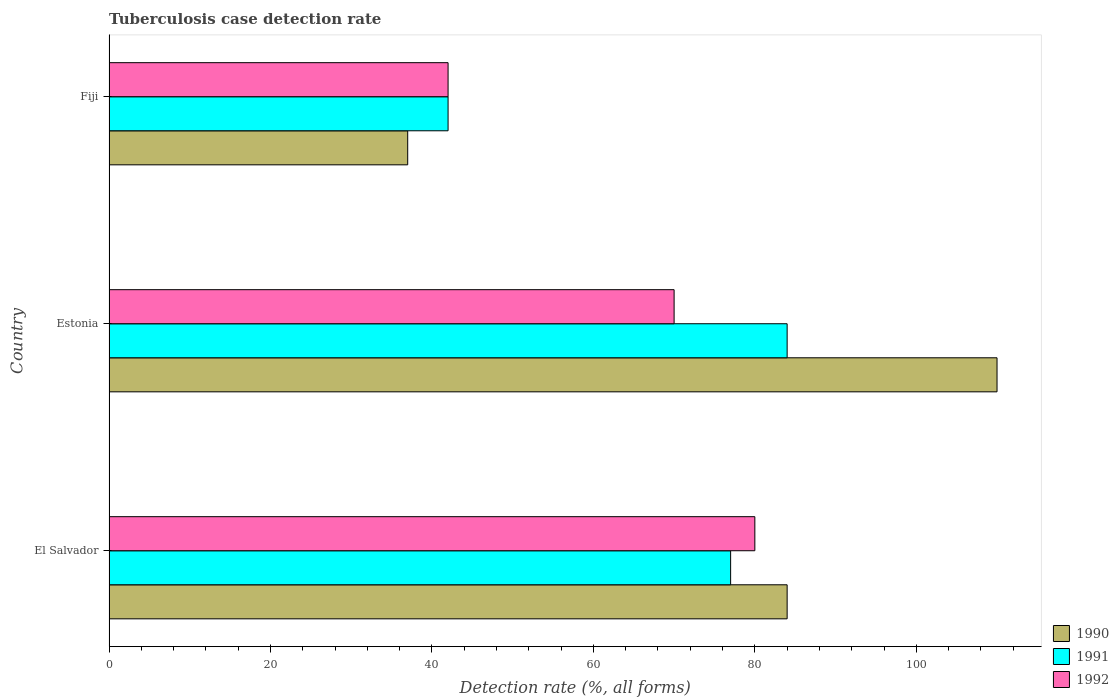How many different coloured bars are there?
Keep it short and to the point. 3. How many groups of bars are there?
Provide a short and direct response. 3. Are the number of bars per tick equal to the number of legend labels?
Your response must be concise. Yes. How many bars are there on the 2nd tick from the top?
Offer a terse response. 3. How many bars are there on the 2nd tick from the bottom?
Provide a succinct answer. 3. What is the label of the 3rd group of bars from the top?
Offer a terse response. El Salvador. Across all countries, what is the maximum tuberculosis case detection rate in in 1990?
Your answer should be very brief. 110. Across all countries, what is the minimum tuberculosis case detection rate in in 1990?
Provide a short and direct response. 37. In which country was the tuberculosis case detection rate in in 1992 maximum?
Offer a very short reply. El Salvador. In which country was the tuberculosis case detection rate in in 1991 minimum?
Offer a very short reply. Fiji. What is the total tuberculosis case detection rate in in 1991 in the graph?
Provide a succinct answer. 203. What is the difference between the tuberculosis case detection rate in in 1992 in El Salvador and the tuberculosis case detection rate in in 1990 in Fiji?
Provide a short and direct response. 43. What is the average tuberculosis case detection rate in in 1992 per country?
Provide a succinct answer. 64. What is the difference between the tuberculosis case detection rate in in 1990 and tuberculosis case detection rate in in 1991 in Estonia?
Make the answer very short. 26. What is the ratio of the tuberculosis case detection rate in in 1992 in Estonia to that in Fiji?
Offer a terse response. 1.67. Is the tuberculosis case detection rate in in 1991 in El Salvador less than that in Fiji?
Give a very brief answer. No. Is the difference between the tuberculosis case detection rate in in 1990 in Estonia and Fiji greater than the difference between the tuberculosis case detection rate in in 1991 in Estonia and Fiji?
Provide a succinct answer. Yes. What is the difference between the highest and the second highest tuberculosis case detection rate in in 1991?
Give a very brief answer. 7. In how many countries, is the tuberculosis case detection rate in in 1991 greater than the average tuberculosis case detection rate in in 1991 taken over all countries?
Keep it short and to the point. 2. Is the sum of the tuberculosis case detection rate in in 1990 in El Salvador and Fiji greater than the maximum tuberculosis case detection rate in in 1992 across all countries?
Your answer should be compact. Yes. What does the 1st bar from the top in El Salvador represents?
Offer a terse response. 1992. How many bars are there?
Keep it short and to the point. 9. Are all the bars in the graph horizontal?
Your answer should be compact. Yes. Does the graph contain any zero values?
Your answer should be compact. No. Where does the legend appear in the graph?
Provide a succinct answer. Bottom right. How are the legend labels stacked?
Offer a very short reply. Vertical. What is the title of the graph?
Your answer should be compact. Tuberculosis case detection rate. What is the label or title of the X-axis?
Keep it short and to the point. Detection rate (%, all forms). What is the Detection rate (%, all forms) in 1990 in El Salvador?
Provide a short and direct response. 84. What is the Detection rate (%, all forms) of 1990 in Estonia?
Make the answer very short. 110. What is the Detection rate (%, all forms) in 1991 in Estonia?
Make the answer very short. 84. What is the Detection rate (%, all forms) in 1992 in Estonia?
Give a very brief answer. 70. What is the Detection rate (%, all forms) in 1991 in Fiji?
Your response must be concise. 42. Across all countries, what is the maximum Detection rate (%, all forms) in 1990?
Keep it short and to the point. 110. Across all countries, what is the maximum Detection rate (%, all forms) in 1991?
Keep it short and to the point. 84. Across all countries, what is the minimum Detection rate (%, all forms) in 1990?
Ensure brevity in your answer.  37. What is the total Detection rate (%, all forms) of 1990 in the graph?
Offer a very short reply. 231. What is the total Detection rate (%, all forms) of 1991 in the graph?
Your answer should be compact. 203. What is the total Detection rate (%, all forms) of 1992 in the graph?
Your answer should be compact. 192. What is the difference between the Detection rate (%, all forms) of 1991 in El Salvador and that in Estonia?
Provide a short and direct response. -7. What is the difference between the Detection rate (%, all forms) in 1990 in El Salvador and that in Fiji?
Ensure brevity in your answer.  47. What is the difference between the Detection rate (%, all forms) of 1991 in El Salvador and that in Fiji?
Provide a short and direct response. 35. What is the difference between the Detection rate (%, all forms) of 1992 in Estonia and that in Fiji?
Provide a succinct answer. 28. What is the difference between the Detection rate (%, all forms) in 1990 in El Salvador and the Detection rate (%, all forms) in 1991 in Estonia?
Make the answer very short. 0. What is the difference between the Detection rate (%, all forms) of 1990 in El Salvador and the Detection rate (%, all forms) of 1992 in Estonia?
Ensure brevity in your answer.  14. What is the difference between the Detection rate (%, all forms) in 1990 in El Salvador and the Detection rate (%, all forms) in 1992 in Fiji?
Make the answer very short. 42. What is the difference between the Detection rate (%, all forms) of 1991 in El Salvador and the Detection rate (%, all forms) of 1992 in Fiji?
Your answer should be compact. 35. What is the difference between the Detection rate (%, all forms) in 1990 in Estonia and the Detection rate (%, all forms) in 1992 in Fiji?
Ensure brevity in your answer.  68. What is the average Detection rate (%, all forms) in 1991 per country?
Keep it short and to the point. 67.67. What is the average Detection rate (%, all forms) of 1992 per country?
Offer a very short reply. 64. What is the difference between the Detection rate (%, all forms) in 1990 and Detection rate (%, all forms) in 1991 in El Salvador?
Provide a succinct answer. 7. What is the difference between the Detection rate (%, all forms) in 1990 and Detection rate (%, all forms) in 1991 in Estonia?
Offer a very short reply. 26. What is the difference between the Detection rate (%, all forms) in 1990 and Detection rate (%, all forms) in 1992 in Estonia?
Ensure brevity in your answer.  40. What is the difference between the Detection rate (%, all forms) of 1991 and Detection rate (%, all forms) of 1992 in Estonia?
Your answer should be very brief. 14. What is the difference between the Detection rate (%, all forms) in 1990 and Detection rate (%, all forms) in 1992 in Fiji?
Provide a short and direct response. -5. What is the ratio of the Detection rate (%, all forms) of 1990 in El Salvador to that in Estonia?
Your answer should be compact. 0.76. What is the ratio of the Detection rate (%, all forms) of 1990 in El Salvador to that in Fiji?
Make the answer very short. 2.27. What is the ratio of the Detection rate (%, all forms) in 1991 in El Salvador to that in Fiji?
Make the answer very short. 1.83. What is the ratio of the Detection rate (%, all forms) of 1992 in El Salvador to that in Fiji?
Give a very brief answer. 1.9. What is the ratio of the Detection rate (%, all forms) in 1990 in Estonia to that in Fiji?
Make the answer very short. 2.97. What is the ratio of the Detection rate (%, all forms) in 1991 in Estonia to that in Fiji?
Give a very brief answer. 2. What is the ratio of the Detection rate (%, all forms) of 1992 in Estonia to that in Fiji?
Ensure brevity in your answer.  1.67. What is the difference between the highest and the second highest Detection rate (%, all forms) of 1990?
Give a very brief answer. 26. What is the difference between the highest and the second highest Detection rate (%, all forms) of 1991?
Your response must be concise. 7. What is the difference between the highest and the second highest Detection rate (%, all forms) in 1992?
Give a very brief answer. 10. What is the difference between the highest and the lowest Detection rate (%, all forms) of 1990?
Keep it short and to the point. 73. 